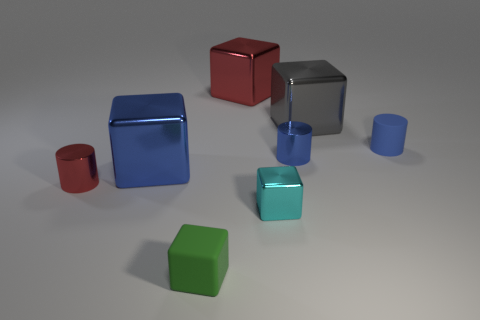There is a tiny metal cylinder that is to the left of the big red shiny block; what color is it?
Your response must be concise. Red. Are there any other things of the same color as the small rubber cylinder?
Your answer should be compact. Yes. Do the blue shiny cylinder and the gray metallic cube have the same size?
Ensure brevity in your answer.  No. There is a shiny thing that is both right of the cyan shiny block and in front of the big gray metal block; what is its size?
Ensure brevity in your answer.  Small. How many large cubes are made of the same material as the large red object?
Provide a short and direct response. 2. The large shiny object that is the same color as the small matte cylinder is what shape?
Ensure brevity in your answer.  Cube. The small rubber block has what color?
Give a very brief answer. Green. There is a rubber thing that is on the right side of the small green matte block; is its shape the same as the green object?
Ensure brevity in your answer.  No. What number of things are either metallic cubes that are right of the large red shiny object or tiny rubber things?
Ensure brevity in your answer.  4. Are there any other small blue things that have the same shape as the small blue metallic thing?
Give a very brief answer. Yes. 